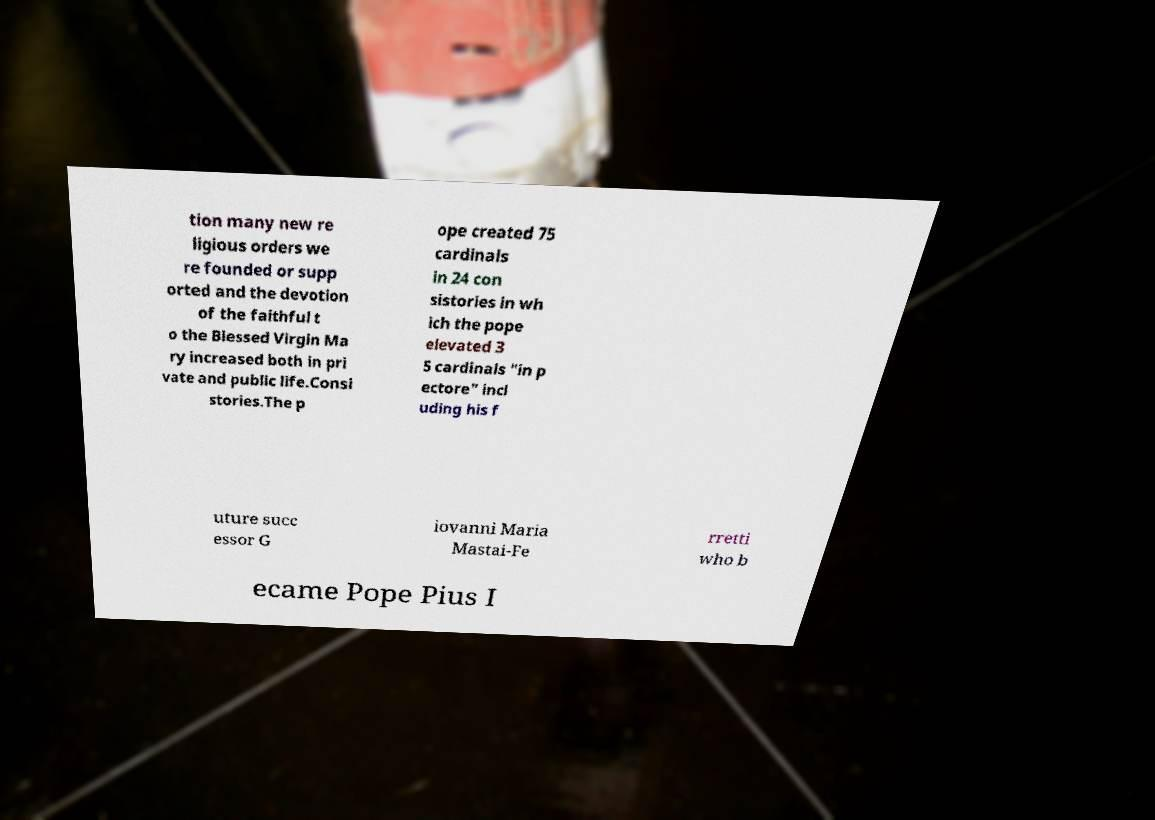What messages or text are displayed in this image? I need them in a readable, typed format. tion many new re ligious orders we re founded or supp orted and the devotion of the faithful t o the Blessed Virgin Ma ry increased both in pri vate and public life.Consi stories.The p ope created 75 cardinals in 24 con sistories in wh ich the pope elevated 3 5 cardinals "in p ectore" incl uding his f uture succ essor G iovanni Maria Mastai-Fe rretti who b ecame Pope Pius I 